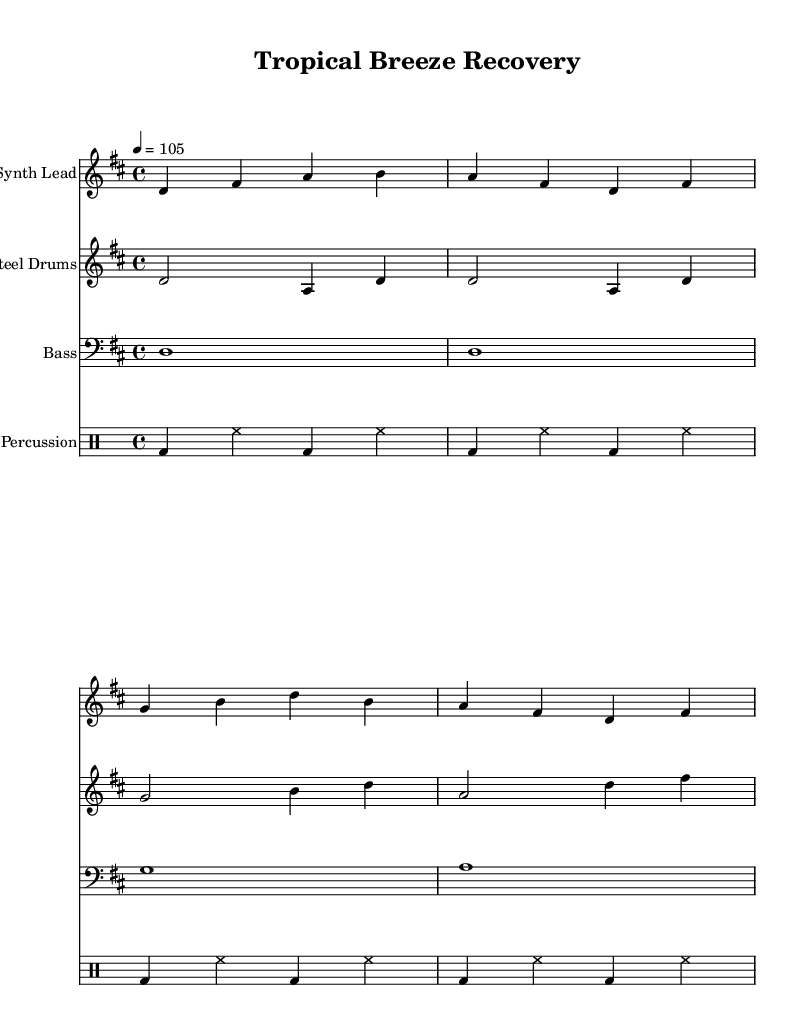What is the key signature of this music? The key signature is D major, identified by two sharps (F# and C#) present at the beginning of the music.
Answer: D major What is the time signature of this music? The time signature shown at the beginning is 4/4, indicating four beats per measure and a quarter note receiving one beat.
Answer: 4/4 What is the tempo marking for this piece? The tempo marking in the music indicates a speed of 105 beats per minute, which is noted next to the word "tempo."
Answer: 105 How many measures are there in the "Synthesis Lead" section? Counting the measures visually in the "Synthesis Lead" staff, you can see there are four distinct measures, making it a total of four.
Answer: 4 What is the main instrument featured in this composition? The main instrument indicated in the score is the "Synth Lead," which is the first staff in the sheet music, suggesting it plays a prominent role.
Answer: Synth Lead What are the two percussion instruments specified in this piece? The percussion section includes "bd" for bass drum and "hh" for hi-hat, which are the two main percussion instruments used in the score.
Answer: Bass drum, hi-hat What is the highest note played in the "Steel Drums" part? By analyzing the notes in the "Steel Drums" staff, the highest note is B, which appears in the third measure of that section.
Answer: B 